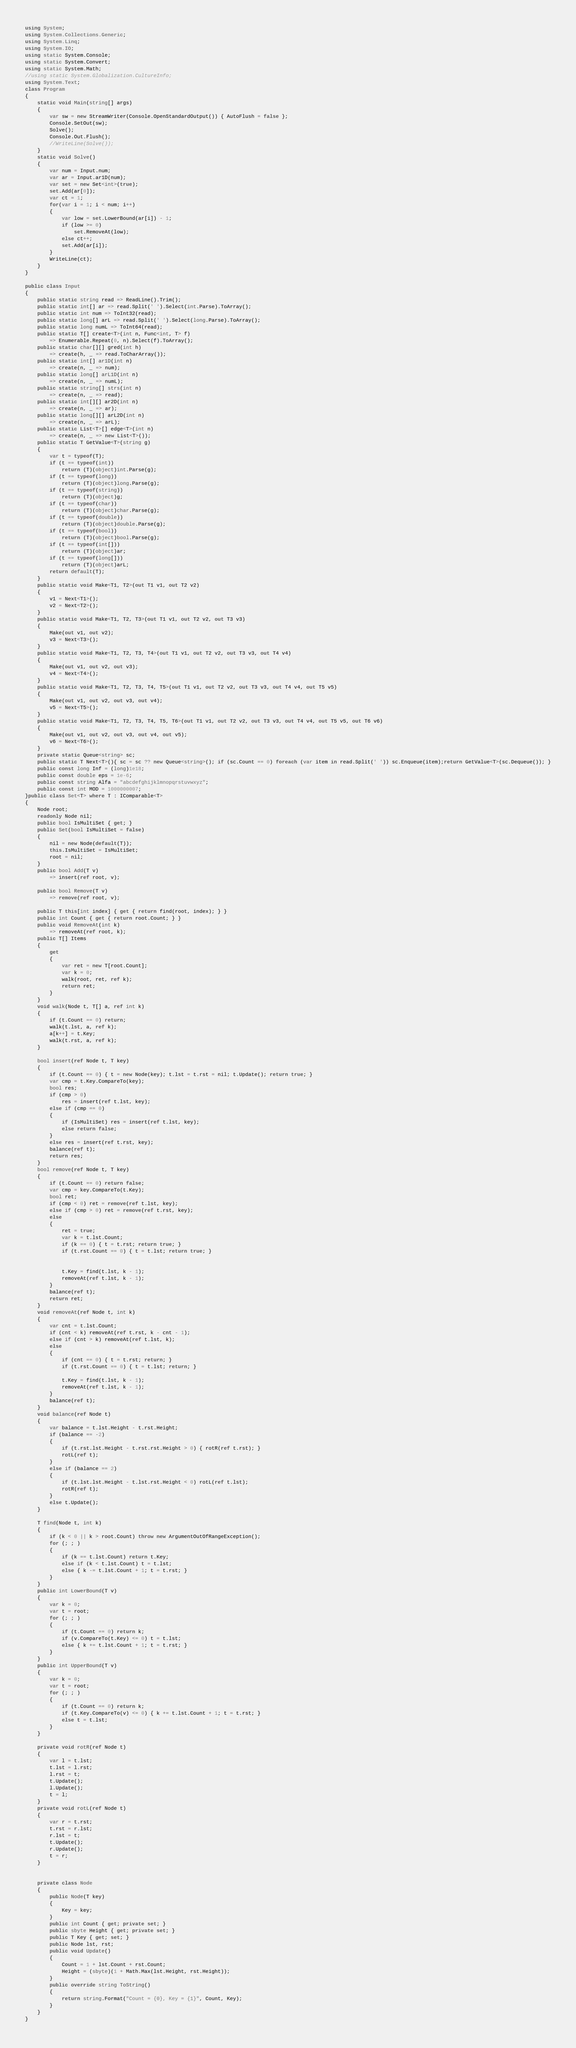Convert code to text. <code><loc_0><loc_0><loc_500><loc_500><_C#_>using System;
using System.Collections.Generic;
using System.Linq;
using System.IO;
using static System.Console;
using static System.Convert;
using static System.Math;
//using static System.Globalization.CultureInfo;
using System.Text;
class Program
{
    static void Main(string[] args)
    {
        var sw = new StreamWriter(Console.OpenStandardOutput()) { AutoFlush = false };
        Console.SetOut(sw);
        Solve();
        Console.Out.Flush();
        //WriteLine(Solve());
    }
    static void Solve()
    {
        var num = Input.num;
        var ar = Input.ar1D(num);
        var set = new Set<int>(true);
        set.Add(ar[0]);
        var ct = 1;
        for(var i = 1; i < num; i++)
        {
            var low = set.LowerBound(ar[i]) - 1;
            if (low >= 0)
                set.RemoveAt(low);
            else ct++;
            set.Add(ar[i]);
        }
        WriteLine(ct);
    }
}

public class Input
{
    public static string read => ReadLine().Trim();
    public static int[] ar => read.Split(' ').Select(int.Parse).ToArray();
    public static int num => ToInt32(read);
    public static long[] arL => read.Split(' ').Select(long.Parse).ToArray();
    public static long numL => ToInt64(read);
    public static T[] create<T>(int n, Func<int, T> f)
        => Enumerable.Repeat(0, n).Select(f).ToArray();
    public static char[][] gred(int h)
        => create(h, _ => read.ToCharArray());
    public static int[] ar1D(int n)
        => create(n, _ => num);
    public static long[] arL1D(int n)
        => create(n, _ => numL);
    public static string[] strs(int n)
        => create(n, _ => read);
    public static int[][] ar2D(int n)
        => create(n, _ => ar);
    public static long[][] arL2D(int n)
        => create(n, _ => arL);
    public static List<T>[] edge<T>(int n)
        => create(n, _ => new List<T>());
    public static T GetValue<T>(string g)
    {
        var t = typeof(T);
        if (t == typeof(int))
            return (T)(object)int.Parse(g);
        if (t == typeof(long))
            return (T)(object)long.Parse(g);
        if (t == typeof(string))
            return (T)(object)g;
        if (t == typeof(char))
            return (T)(object)char.Parse(g);
        if (t == typeof(double))
            return (T)(object)double.Parse(g);
        if (t == typeof(bool))
            return (T)(object)bool.Parse(g);
        if (t == typeof(int[]))
            return (T)(object)ar;
        if (t == typeof(long[]))
            return (T)(object)arL;
        return default(T);
    }
    public static void Make<T1, T2>(out T1 v1, out T2 v2)
    {
        v1 = Next<T1>();
        v2 = Next<T2>();
    }
    public static void Make<T1, T2, T3>(out T1 v1, out T2 v2, out T3 v3)
    {
        Make(out v1, out v2);
        v3 = Next<T3>();
    }
    public static void Make<T1, T2, T3, T4>(out T1 v1, out T2 v2, out T3 v3, out T4 v4)
    {
        Make(out v1, out v2, out v3);
        v4 = Next<T4>();
    }
    public static void Make<T1, T2, T3, T4, T5>(out T1 v1, out T2 v2, out T3 v3, out T4 v4, out T5 v5)
    {
        Make(out v1, out v2, out v3, out v4);
        v5 = Next<T5>();
    }
    public static void Make<T1, T2, T3, T4, T5, T6>(out T1 v1, out T2 v2, out T3 v3, out T4 v4, out T5 v5, out T6 v6)
    {
        Make(out v1, out v2, out v3, out v4, out v5);
        v6 = Next<T6>();
    }
    private static Queue<string> sc;
    public static T Next<T>(){ sc = sc ?? new Queue<string>(); if (sc.Count == 0) foreach (var item in read.Split(' ')) sc.Enqueue(item);return GetValue<T>(sc.Dequeue()); }
    public const long Inf = (long)1e18;
    public const double eps = 1e-6;
    public const string Alfa = "abcdefghijklmnopqrstuvwxyz";
    public const int MOD = 1000000007;
}public class Set<T> where T : IComparable<T>
{
    Node root;
    readonly Node nil;
    public bool IsMultiSet { get; }
    public Set(bool IsMultiSet = false)
    {
        nil = new Node(default(T));
        this.IsMultiSet = IsMultiSet;
        root = nil;
    }
    public bool Add(T v)
        => insert(ref root, v);

    public bool Remove(T v)
        => remove(ref root, v);

    public T this[int index] { get { return find(root, index); } }
    public int Count { get { return root.Count; } }
    public void RemoveAt(int k)
        => removeAt(ref root, k);
    public T[] Items
    {
        get
        {
            var ret = new T[root.Count];
            var k = 0;
            walk(root, ret, ref k);
            return ret;
        }
    }
    void walk(Node t, T[] a, ref int k)
    {
        if (t.Count == 0) return;
        walk(t.lst, a, ref k);
        a[k++] = t.Key;
        walk(t.rst, a, ref k);
    }

    bool insert(ref Node t, T key)
    {
        if (t.Count == 0) { t = new Node(key); t.lst = t.rst = nil; t.Update(); return true; }
        var cmp = t.Key.CompareTo(key);
        bool res;
        if (cmp > 0)
            res = insert(ref t.lst, key);
        else if (cmp == 0)
        {
            if (IsMultiSet) res = insert(ref t.lst, key);
            else return false;
        }
        else res = insert(ref t.rst, key);
        balance(ref t);
        return res;
    }
    bool remove(ref Node t, T key)
    {
        if (t.Count == 0) return false;
        var cmp = key.CompareTo(t.Key);
        bool ret;
        if (cmp < 0) ret = remove(ref t.lst, key);
        else if (cmp > 0) ret = remove(ref t.rst, key);
        else
        {
            ret = true;
            var k = t.lst.Count;
            if (k == 0) { t = t.rst; return true; }
            if (t.rst.Count == 0) { t = t.lst; return true; }


            t.Key = find(t.lst, k - 1);
            removeAt(ref t.lst, k - 1);
        }
        balance(ref t);
        return ret;
    }
    void removeAt(ref Node t, int k)
    {
        var cnt = t.lst.Count;
        if (cnt < k) removeAt(ref t.rst, k - cnt - 1);
        else if (cnt > k) removeAt(ref t.lst, k);
        else
        {
            if (cnt == 0) { t = t.rst; return; }
            if (t.rst.Count == 0) { t = t.lst; return; }

            t.Key = find(t.lst, k - 1);
            removeAt(ref t.lst, k - 1);
        }
        balance(ref t);
    }
    void balance(ref Node t)
    {
        var balance = t.lst.Height - t.rst.Height;
        if (balance == -2)
        {
            if (t.rst.lst.Height - t.rst.rst.Height > 0) { rotR(ref t.rst); }
            rotL(ref t);
        }
        else if (balance == 2)
        {
            if (t.lst.lst.Height - t.lst.rst.Height < 0) rotL(ref t.lst);
            rotR(ref t);
        }
        else t.Update();
    }

    T find(Node t, int k)
    {
        if (k < 0 || k > root.Count) throw new ArgumentOutOfRangeException();
        for (; ; )
        {
            if (k == t.lst.Count) return t.Key;
            else if (k < t.lst.Count) t = t.lst;
            else { k -= t.lst.Count + 1; t = t.rst; }
        }
    }
    public int LowerBound(T v)
    {
        var k = 0;
        var t = root;
        for (; ; )
        {
            if (t.Count == 0) return k;
            if (v.CompareTo(t.Key) <= 0) t = t.lst;
            else { k += t.lst.Count + 1; t = t.rst; }
        }
    }
    public int UpperBound(T v)
    {
        var k = 0;
        var t = root;
        for (; ; )
        {
            if (t.Count == 0) return k;
            if (t.Key.CompareTo(v) <= 0) { k += t.lst.Count + 1; t = t.rst; }
            else t = t.lst;
        }
    }

    private void rotR(ref Node t)
    {
        var l = t.lst;
        t.lst = l.rst;
        l.rst = t;
        t.Update();
        l.Update();
        t = l;
    }
    private void rotL(ref Node t)
    {
        var r = t.rst;
        t.rst = r.lst;
        r.lst = t;
        t.Update();
        r.Update();
        t = r;
    }


    private class Node
    {
        public Node(T key)
        {
            Key = key;
        }
        public int Count { get; private set; }
        public sbyte Height { get; private set; }
        public T Key { get; set; }
        public Node lst, rst;
        public void Update()
        {
            Count = 1 + lst.Count + rst.Count;
            Height = (sbyte)(1 + Math.Max(lst.Height, rst.Height));
        }
        public override string ToString()
        {
            return string.Format("Count = {0}, Key = {1}", Count, Key);
        }
    }
}</code> 